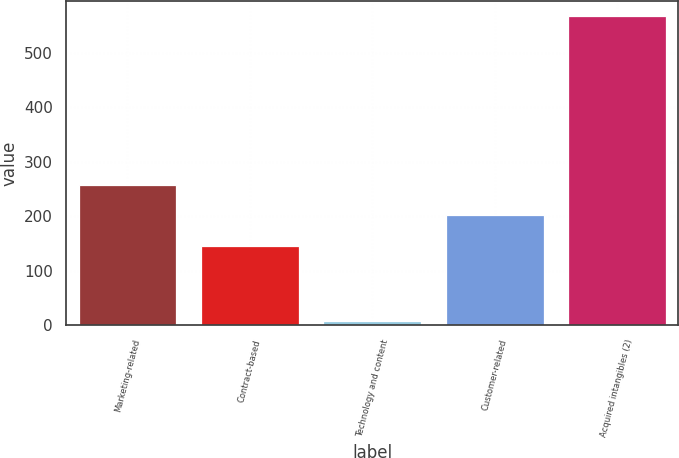Convert chart. <chart><loc_0><loc_0><loc_500><loc_500><bar_chart><fcel>Marketing-related<fcel>Contract-based<fcel>Technology and content<fcel>Customer-related<fcel>Acquired intangibles (2)<nl><fcel>257.8<fcel>146<fcel>8<fcel>201.9<fcel>567<nl></chart> 